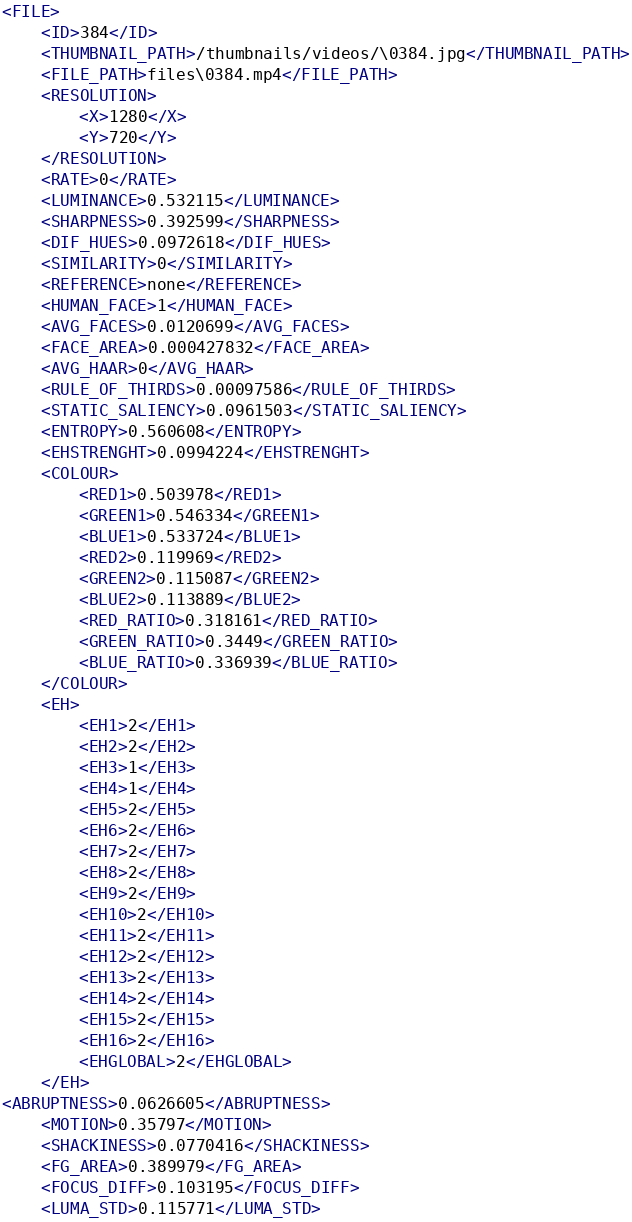<code> <loc_0><loc_0><loc_500><loc_500><_XML_><FILE>
	<ID>384</ID>
	<THUMBNAIL_PATH>/thumbnails/videos/\0384.jpg</THUMBNAIL_PATH>
	<FILE_PATH>files\0384.mp4</FILE_PATH>
	<RESOLUTION>
		<X>1280</X>
		<Y>720</Y>
	</RESOLUTION>
	<RATE>0</RATE>
	<LUMINANCE>0.532115</LUMINANCE>
	<SHARPNESS>0.392599</SHARPNESS>
	<DIF_HUES>0.0972618</DIF_HUES>
	<SIMILARITY>0</SIMILARITY>
	<REFERENCE>none</REFERENCE>
	<HUMAN_FACE>1</HUMAN_FACE>
	<AVG_FACES>0.0120699</AVG_FACES>
	<FACE_AREA>0.000427832</FACE_AREA>
	<AVG_HAAR>0</AVG_HAAR>
	<RULE_OF_THIRDS>0.00097586</RULE_OF_THIRDS>
	<STATIC_SALIENCY>0.0961503</STATIC_SALIENCY>
	<ENTROPY>0.560608</ENTROPY>
	<EHSTRENGHT>0.0994224</EHSTRENGHT>
	<COLOUR>
		<RED1>0.503978</RED1>
		<GREEN1>0.546334</GREEN1>
		<BLUE1>0.533724</BLUE1>
		<RED2>0.119969</RED2>
		<GREEN2>0.115087</GREEN2>
		<BLUE2>0.113889</BLUE2>
		<RED_RATIO>0.318161</RED_RATIO>
		<GREEN_RATIO>0.3449</GREEN_RATIO>
		<BLUE_RATIO>0.336939</BLUE_RATIO>
	</COLOUR>
	<EH>
		<EH1>2</EH1>
		<EH2>2</EH2>
		<EH3>1</EH3>
		<EH4>1</EH4>
		<EH5>2</EH5>
		<EH6>2</EH6>
		<EH7>2</EH7>
		<EH8>2</EH8>
		<EH9>2</EH9>
		<EH10>2</EH10>
		<EH11>2</EH11>
		<EH12>2</EH12>
		<EH13>2</EH13>
		<EH14>2</EH14>
		<EH15>2</EH15>
		<EH16>2</EH16>
		<EHGLOBAL>2</EHGLOBAL>
	</EH>
<ABRUPTNESS>0.0626605</ABRUPTNESS>
	<MOTION>0.35797</MOTION>
	<SHACKINESS>0.0770416</SHACKINESS>
	<FG_AREA>0.389979</FG_AREA>
	<FOCUS_DIFF>0.103195</FOCUS_DIFF>
	<LUMA_STD>0.115771</LUMA_STD></code> 